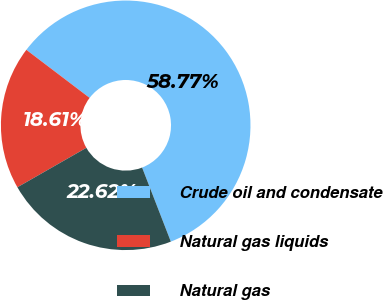Convert chart. <chart><loc_0><loc_0><loc_500><loc_500><pie_chart><fcel>Crude oil and condensate<fcel>Natural gas liquids<fcel>Natural gas<nl><fcel>58.77%<fcel>18.61%<fcel>22.62%<nl></chart> 